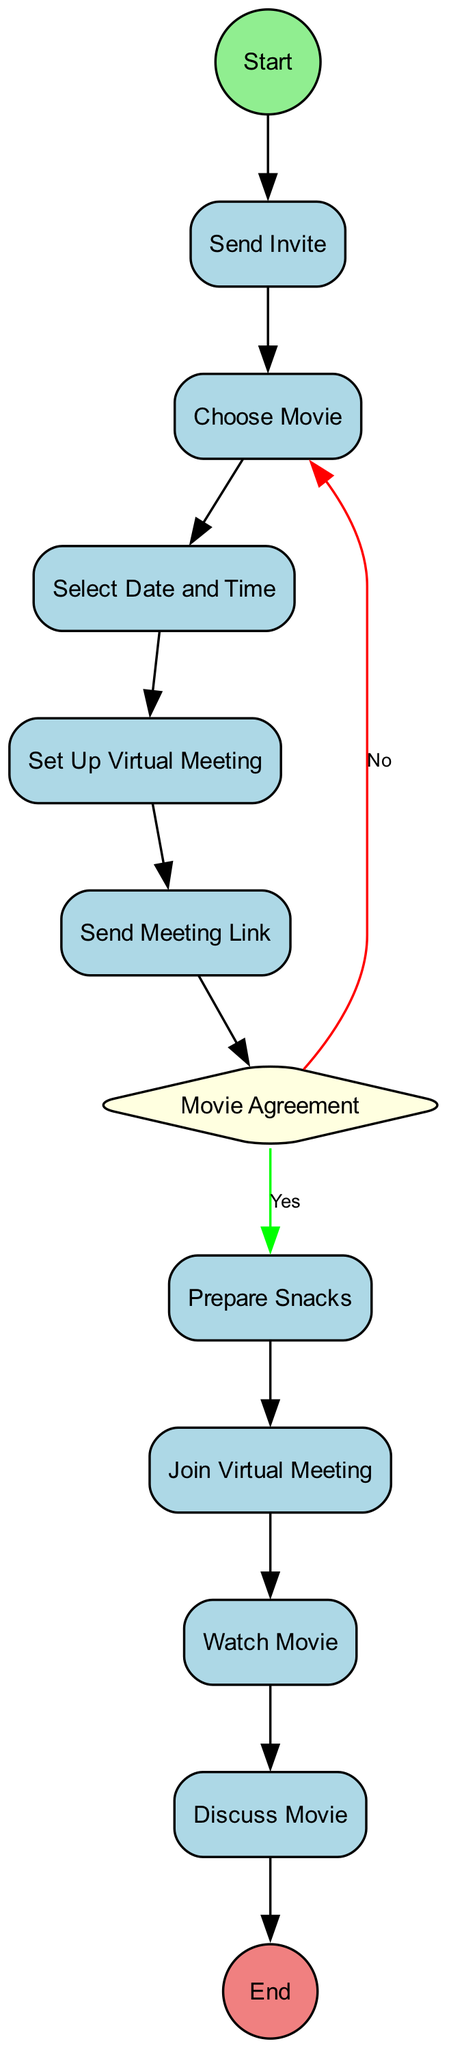What is the first action in the diagram? The first action in the diagram is 'Send Invite'. It is the first node connected to the 'Start' node, indicating the initial step in the process of planning a virtual movie night.
Answer: Send Invite How many actions are there in the diagram? The diagram contains a total of eight actions. These consist of sending invites, choosing a movie, selecting a date and time, setting up a virtual meeting, sending the meeting link, preparing snacks, joining the virtual meeting, and watching the movie. Each of these actions is represented by a node.
Answer: Eight What happens if friends do not agree on the movie choice? If friends do not agree on the movie choice, the diagram indicates the flow goes back to the 'Choose Movie' action based on the 'No' path from the decision node labeled 'Movie Agreement'. This means they need to reselect the movie until an agreement is reached.
Answer: Choose Movie What is the last action before the end of the process? The last action before reaching the 'End' of the process is 'Discuss Movie', which comes after 'Watch Movie'. This indicates that after watching the movie, the group engages in a discussion, concluding the activity.
Answer: Discuss Movie How many decisions are present in the diagram? The diagram includes one decision. It focuses on whether all friends agree on the movie choice, which dictates the subsequent actions in the diagram. If the answer is 'No', the process loops back; if 'Yes', it moves forward.
Answer: One What are the paths stemming from the decision node labeled 'Movie Agreement'? The paths stemming from the decision node allow for two outcomes: 'Yes', which leads to the 'Prepare Snacks' action, and 'No', which circles back to 'Choose Movie'. This indicates a loop to allow for further movie selection if there is disagreement.
Answer: Yes, No What does the diagram indicate happens after preparing snacks? After preparing snacks, the next action according to the diagram is to 'Join Virtual Meeting'. This indicates the sequence of activities leading up to the actual movie-watching event.
Answer: Join Virtual Meeting What color is the decision node in the diagram? The decision node is colored light yellow. This color choice helps differentiate it from action nodes and highlights its role in determining the course of the activity based on group consensus.
Answer: Light yellow 